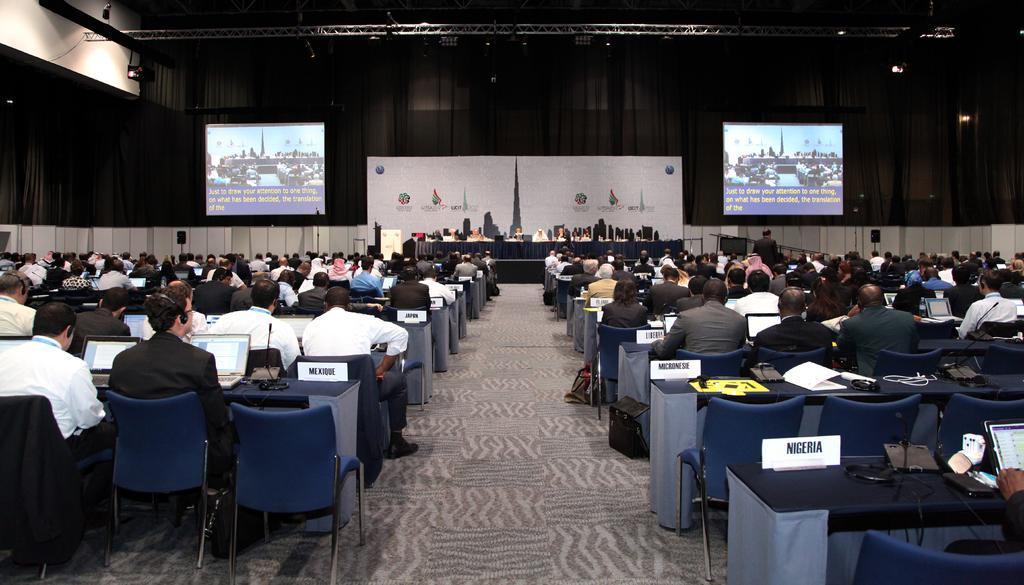In one or two sentences, can you explain what this image depicts? In this Image I see number of people who are sitting on chairs and there are tables in front of them on which there are name boards and laptops. In the background I see 2 screens, a board and few people over here too and I can see the lights. 